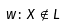Convert formula to latex. <formula><loc_0><loc_0><loc_500><loc_500>w \colon X \notin L</formula> 